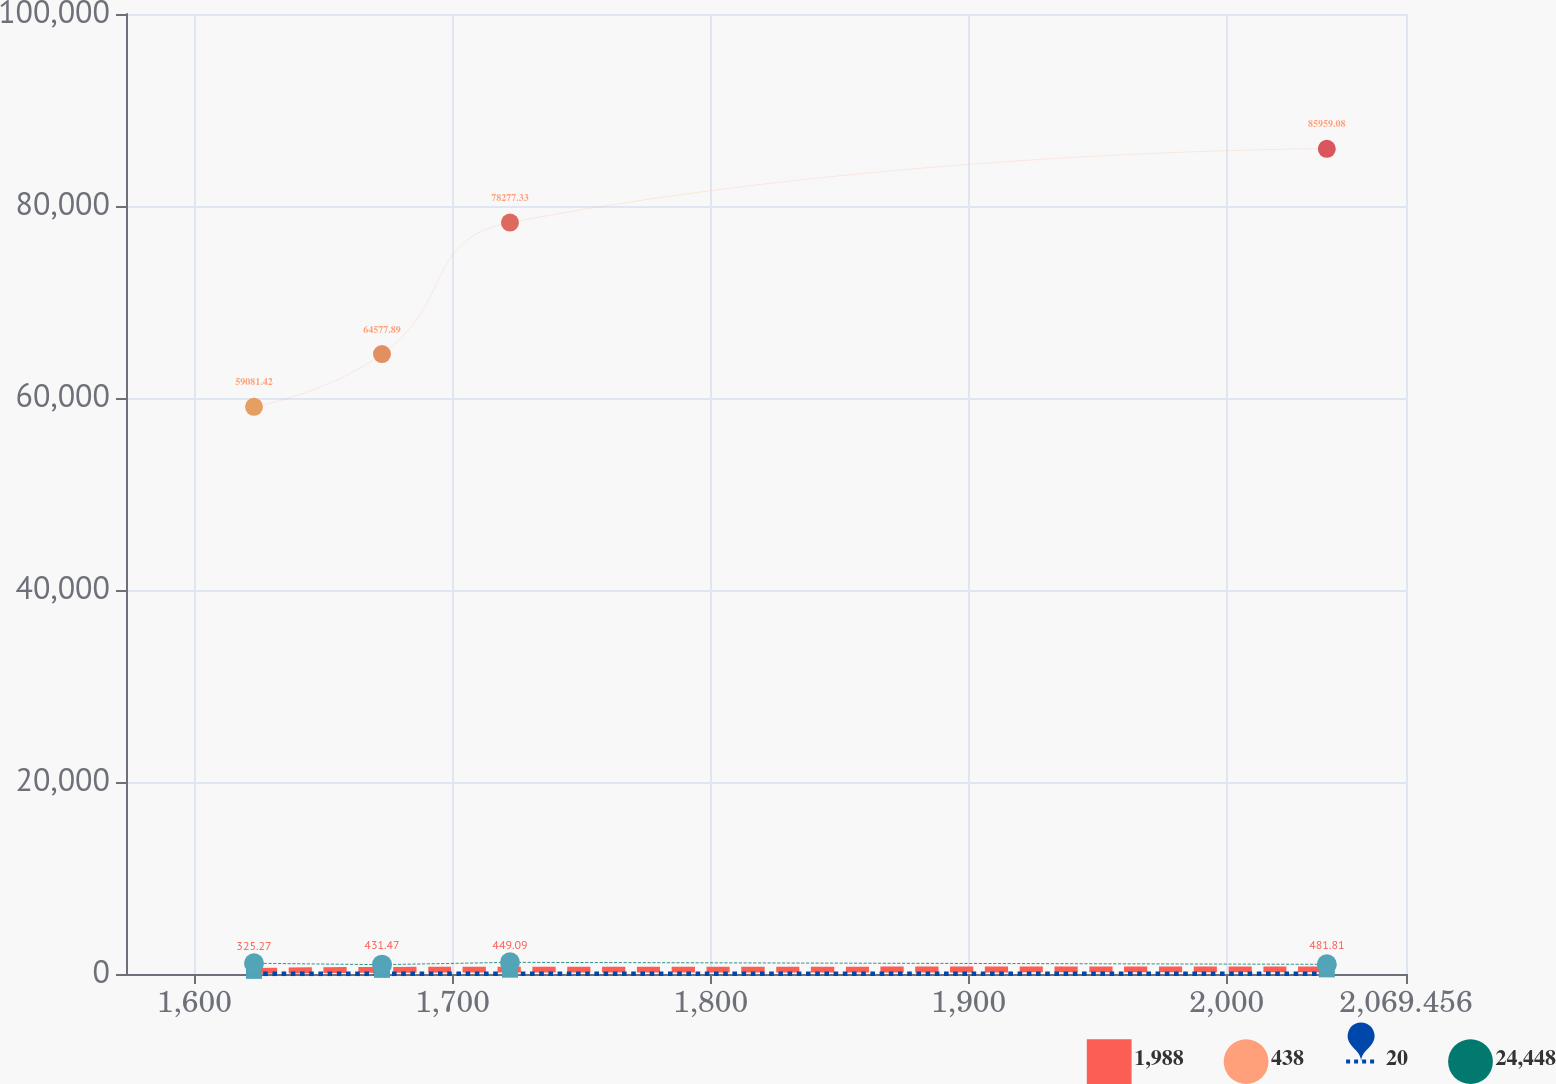Convert chart to OTSL. <chart><loc_0><loc_0><loc_500><loc_500><line_chart><ecel><fcel>1,988<fcel>438<fcel>20<fcel>24,448<nl><fcel>1623.11<fcel>325.27<fcel>59081.4<fcel>17.71<fcel>1117.27<nl><fcel>1672.7<fcel>431.47<fcel>64577.9<fcel>16.75<fcel>971.83<nl><fcel>1722.29<fcel>449.09<fcel>78277.3<fcel>23.96<fcel>1214.57<nl><fcel>2038.78<fcel>481.81<fcel>85959.1<fcel>20.61<fcel>1007.41<nl><fcel>2119.05<fcel>501.46<fcel>88657<fcel>19.89<fcel>1170.96<nl></chart> 